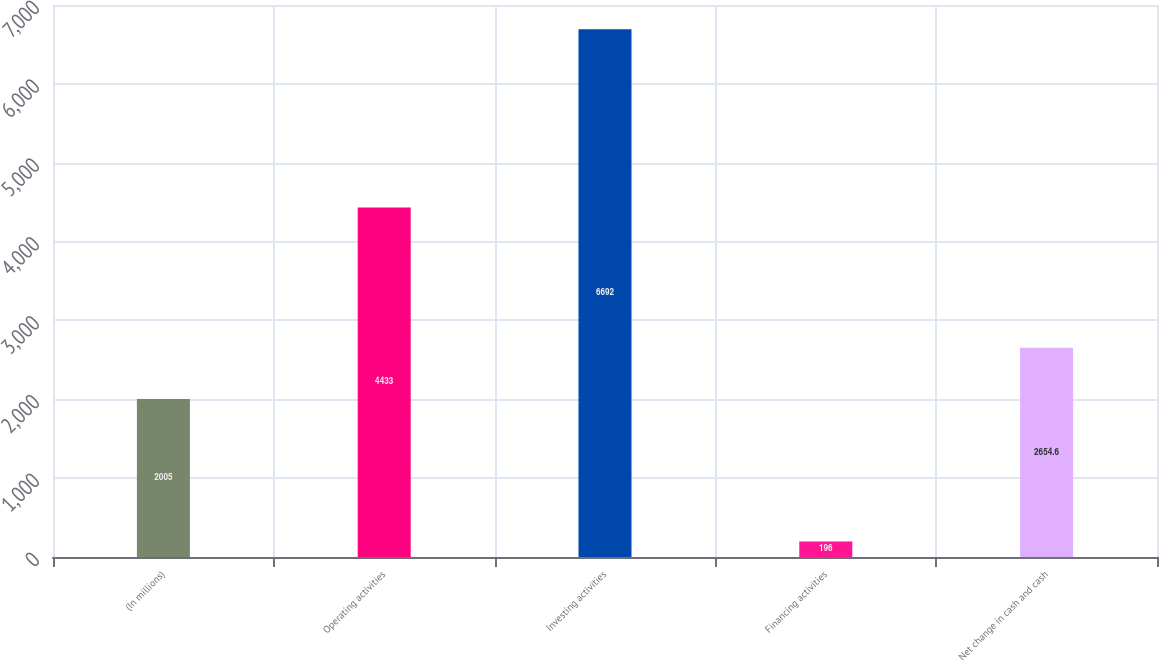Convert chart to OTSL. <chart><loc_0><loc_0><loc_500><loc_500><bar_chart><fcel>(In millions)<fcel>Operating activities<fcel>Investing activities<fcel>Financing activities<fcel>Net change in cash and cash<nl><fcel>2005<fcel>4433<fcel>6692<fcel>196<fcel>2654.6<nl></chart> 